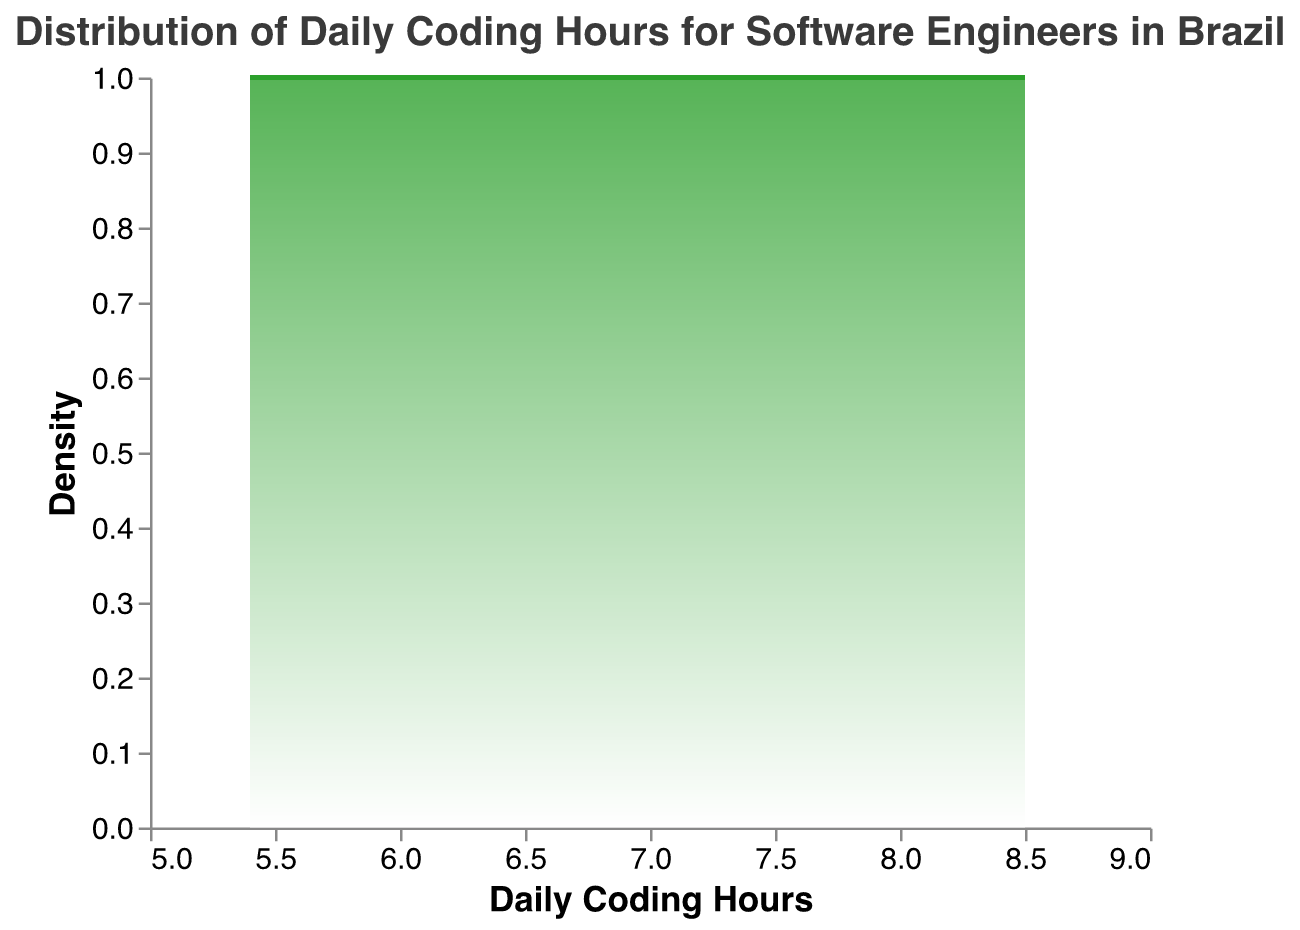What is the title of the figure? The title is usually placed at the top of the figure and reflects the content or purpose of the plot. In this case, the title can be found in the code under the "title" attribute.
Answer: "Distribution of Daily Coding Hours for Software Engineers in Brazil" What does the x-axis represent? The x-axis typically displays the variable being measured or compared. According to the provided code, the x-axis field is "DailyCodingHours".
Answer: Daily Coding Hours What does the y-axis represent? The y-axis often shows the measurement or frequency of the values on the x-axis. The code indicates the y-axis is titled "Density".
Answer: Density What color gradient is used in the density plot? The color gradient is used to enhance the visual representation of the density. The gradient runs from white to a specific color reflected in the plot's opacity and linear gradient stops.
Answer: White to green Which range of daily coding hours has the highest density? To find the highest density, look at the peak of the density plot. The peak represents the range where the highest number of observations falls.
Answer: Around 6.8 to 7.0 hours Do more engineers code closer to 6 hours or 8 hours per day? By comparing the densities at 6 hours and 8 hours, you can determine where the density is higher.
Answer: Closer to 6 hours What is the approximate median of daily coding hours? The median can be approximated by looking at the point on the x-axis where the plot seems to divide into two roughly equal areas.
Answer: Around 7.0 hours Are there any outliers in this distribution? In a density plot, outliers appear as observations far off from the central part of the distribution. Look for any abnormal spikes or tails in the data.
Answer: No significant outliers Is the distribution of daily coding hours skewed? Skewness can be identified by looking at the symmetry of the density plot. If the plot extends more to one side than the other, it indicates skewness.
Answer: Slightly right-skewed 